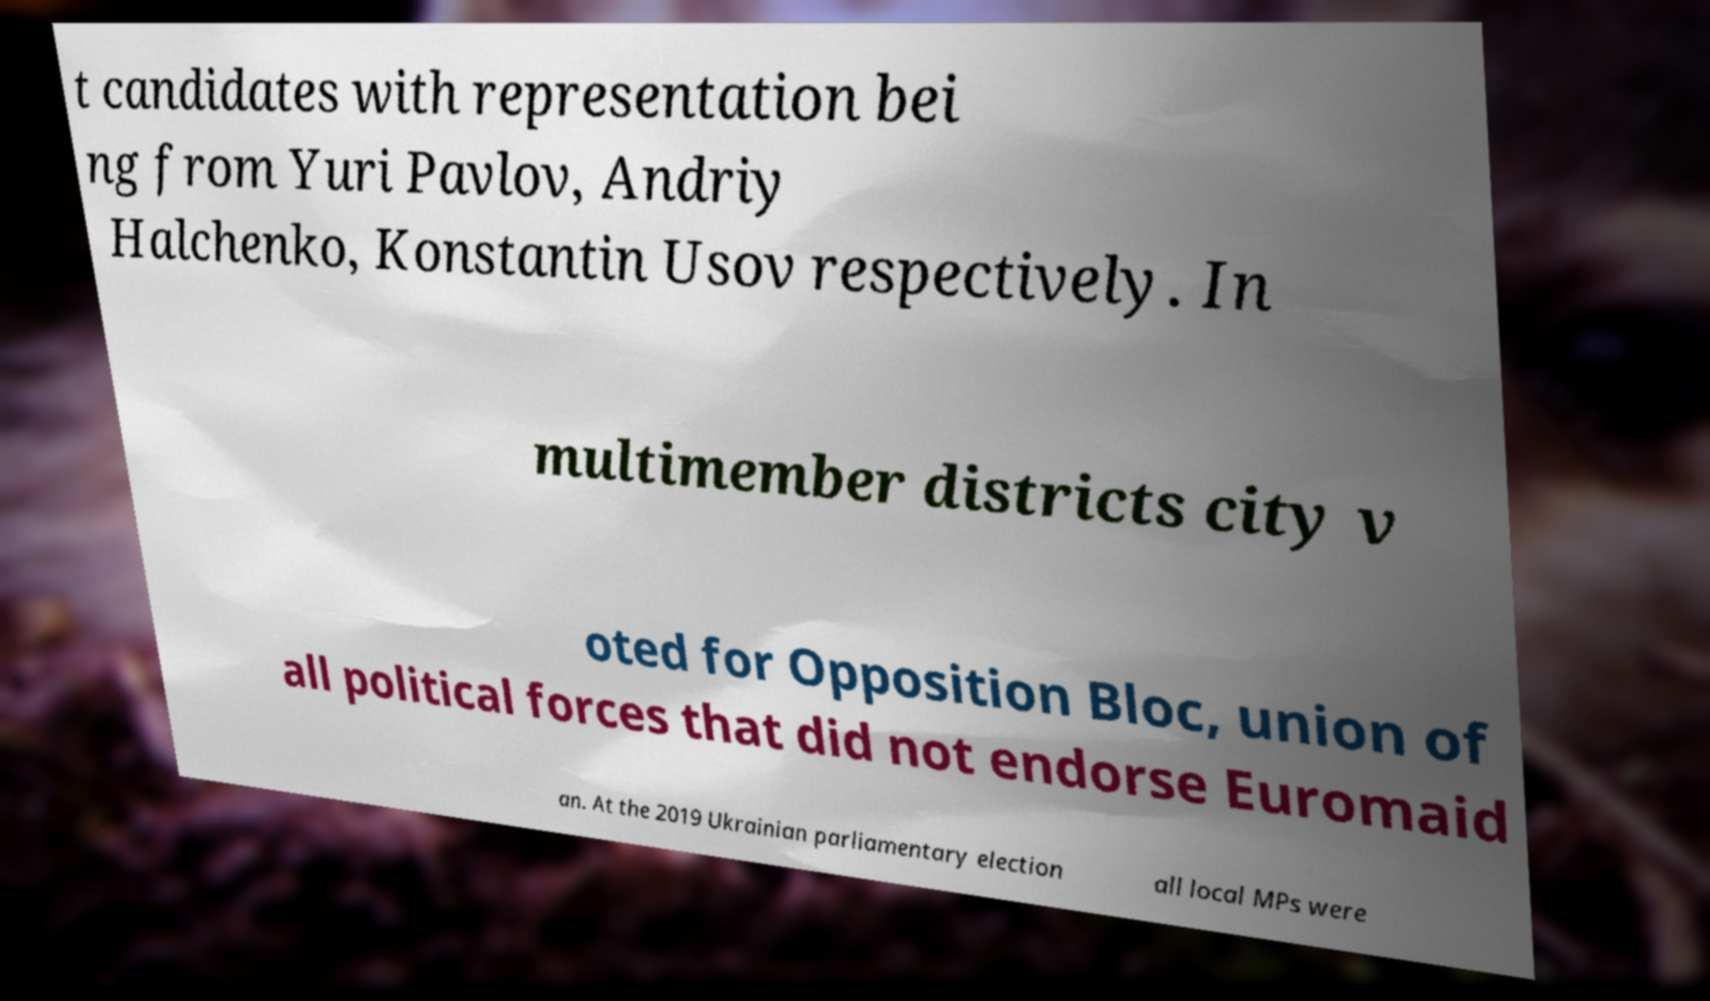Can you read and provide the text displayed in the image?This photo seems to have some interesting text. Can you extract and type it out for me? t candidates with representation bei ng from Yuri Pavlov, Andriy Halchenko, Konstantin Usov respectively. In multimember districts city v oted for Opposition Bloc, union of all political forces that did not endorse Euromaid an. At the 2019 Ukrainian parliamentary election all local MPs were 